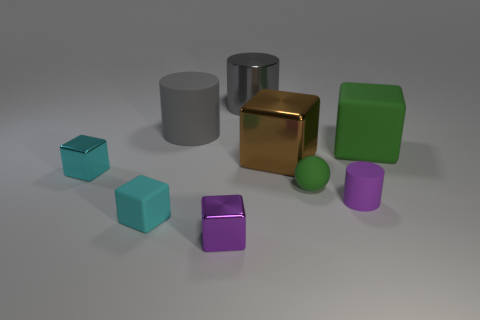Subtract all gray spheres. How many cyan blocks are left? 2 Subtract all small purple rubber cylinders. How many cylinders are left? 2 Subtract 2 blocks. How many blocks are left? 3 Subtract all green blocks. How many blocks are left? 4 Add 1 small purple metal cubes. How many objects exist? 10 Subtract all red cylinders. Subtract all purple spheres. How many cylinders are left? 3 Subtract all spheres. How many objects are left? 8 Subtract all big green metallic cubes. Subtract all large gray shiny objects. How many objects are left? 8 Add 4 tiny metal things. How many tiny metal things are left? 6 Add 8 tiny metallic things. How many tiny metallic things exist? 10 